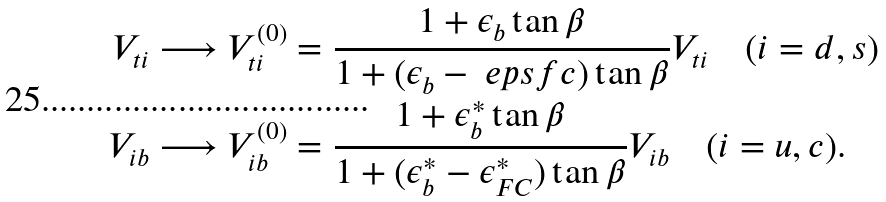Convert formula to latex. <formula><loc_0><loc_0><loc_500><loc_500>V _ { t i } & \longrightarrow V _ { t i } ^ { ( 0 ) } = \frac { 1 + \epsilon _ { b } \tan \beta } { 1 + ( \epsilon _ { b } - \ e p s f c ) \tan \beta } V _ { t i } \quad ( i = d , s ) \\ V _ { i b } & \longrightarrow V _ { i b } ^ { ( 0 ) } = \frac { 1 + \epsilon ^ { * } _ { b } \tan \beta } { 1 + ( \epsilon ^ { * } _ { b } - \epsilon ^ { * } _ { F C } ) \tan \beta } V _ { i b } \quad ( i = u , c ) .</formula> 